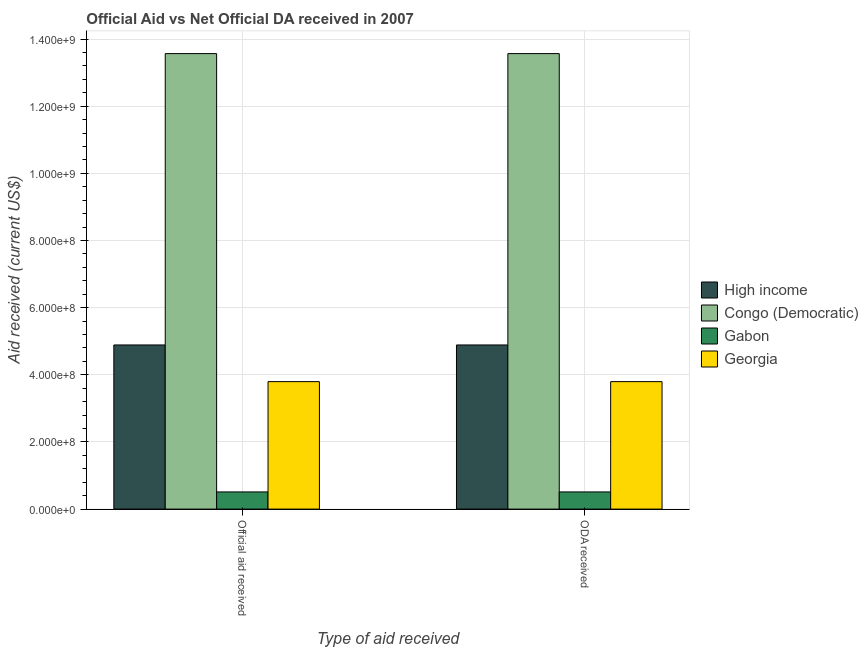How many different coloured bars are there?
Your answer should be very brief. 4. Are the number of bars per tick equal to the number of legend labels?
Offer a terse response. Yes. Are the number of bars on each tick of the X-axis equal?
Offer a terse response. Yes. How many bars are there on the 1st tick from the left?
Your response must be concise. 4. What is the label of the 1st group of bars from the left?
Your answer should be compact. Official aid received. What is the oda received in Gabon?
Give a very brief answer. 5.11e+07. Across all countries, what is the maximum official aid received?
Offer a terse response. 1.36e+09. Across all countries, what is the minimum official aid received?
Offer a very short reply. 5.11e+07. In which country was the official aid received maximum?
Provide a succinct answer. Congo (Democratic). In which country was the official aid received minimum?
Offer a very short reply. Gabon. What is the total oda received in the graph?
Your response must be concise. 2.28e+09. What is the difference between the oda received in High income and that in Congo (Democratic)?
Your answer should be compact. -8.68e+08. What is the difference between the oda received in Congo (Democratic) and the official aid received in Gabon?
Your answer should be compact. 1.31e+09. What is the average oda received per country?
Your answer should be compact. 5.69e+08. In how many countries, is the oda received greater than 1120000000 US$?
Offer a very short reply. 1. What is the ratio of the oda received in High income to that in Gabon?
Give a very brief answer. 9.56. What does the 4th bar from the left in Official aid received represents?
Your answer should be compact. Georgia. What does the 2nd bar from the right in ODA received represents?
Ensure brevity in your answer.  Gabon. Are the values on the major ticks of Y-axis written in scientific E-notation?
Ensure brevity in your answer.  Yes. Does the graph contain grids?
Your answer should be very brief. Yes. Where does the legend appear in the graph?
Give a very brief answer. Center right. How many legend labels are there?
Your response must be concise. 4. What is the title of the graph?
Make the answer very short. Official Aid vs Net Official DA received in 2007 . What is the label or title of the X-axis?
Keep it short and to the point. Type of aid received. What is the label or title of the Y-axis?
Provide a succinct answer. Aid received (current US$). What is the Aid received (current US$) of High income in Official aid received?
Give a very brief answer. 4.89e+08. What is the Aid received (current US$) in Congo (Democratic) in Official aid received?
Keep it short and to the point. 1.36e+09. What is the Aid received (current US$) in Gabon in Official aid received?
Keep it short and to the point. 5.11e+07. What is the Aid received (current US$) in Georgia in Official aid received?
Provide a succinct answer. 3.80e+08. What is the Aid received (current US$) of High income in ODA received?
Offer a terse response. 4.89e+08. What is the Aid received (current US$) in Congo (Democratic) in ODA received?
Make the answer very short. 1.36e+09. What is the Aid received (current US$) in Gabon in ODA received?
Ensure brevity in your answer.  5.11e+07. What is the Aid received (current US$) in Georgia in ODA received?
Give a very brief answer. 3.80e+08. Across all Type of aid received, what is the maximum Aid received (current US$) of High income?
Keep it short and to the point. 4.89e+08. Across all Type of aid received, what is the maximum Aid received (current US$) in Congo (Democratic)?
Offer a very short reply. 1.36e+09. Across all Type of aid received, what is the maximum Aid received (current US$) in Gabon?
Offer a very short reply. 5.11e+07. Across all Type of aid received, what is the maximum Aid received (current US$) of Georgia?
Keep it short and to the point. 3.80e+08. Across all Type of aid received, what is the minimum Aid received (current US$) in High income?
Provide a succinct answer. 4.89e+08. Across all Type of aid received, what is the minimum Aid received (current US$) in Congo (Democratic)?
Your response must be concise. 1.36e+09. Across all Type of aid received, what is the minimum Aid received (current US$) in Gabon?
Your response must be concise. 5.11e+07. Across all Type of aid received, what is the minimum Aid received (current US$) in Georgia?
Give a very brief answer. 3.80e+08. What is the total Aid received (current US$) in High income in the graph?
Your answer should be compact. 9.78e+08. What is the total Aid received (current US$) in Congo (Democratic) in the graph?
Provide a short and direct response. 2.71e+09. What is the total Aid received (current US$) of Gabon in the graph?
Ensure brevity in your answer.  1.02e+08. What is the total Aid received (current US$) in Georgia in the graph?
Ensure brevity in your answer.  7.59e+08. What is the difference between the Aid received (current US$) in High income in Official aid received and that in ODA received?
Offer a terse response. 0. What is the difference between the Aid received (current US$) of High income in Official aid received and the Aid received (current US$) of Congo (Democratic) in ODA received?
Your answer should be compact. -8.68e+08. What is the difference between the Aid received (current US$) of High income in Official aid received and the Aid received (current US$) of Gabon in ODA received?
Provide a short and direct response. 4.38e+08. What is the difference between the Aid received (current US$) of High income in Official aid received and the Aid received (current US$) of Georgia in ODA received?
Your answer should be very brief. 1.09e+08. What is the difference between the Aid received (current US$) in Congo (Democratic) in Official aid received and the Aid received (current US$) in Gabon in ODA received?
Your answer should be very brief. 1.31e+09. What is the difference between the Aid received (current US$) of Congo (Democratic) in Official aid received and the Aid received (current US$) of Georgia in ODA received?
Provide a succinct answer. 9.77e+08. What is the difference between the Aid received (current US$) of Gabon in Official aid received and the Aid received (current US$) of Georgia in ODA received?
Make the answer very short. -3.29e+08. What is the average Aid received (current US$) of High income per Type of aid received?
Keep it short and to the point. 4.89e+08. What is the average Aid received (current US$) of Congo (Democratic) per Type of aid received?
Offer a terse response. 1.36e+09. What is the average Aid received (current US$) of Gabon per Type of aid received?
Offer a terse response. 5.11e+07. What is the average Aid received (current US$) in Georgia per Type of aid received?
Ensure brevity in your answer.  3.80e+08. What is the difference between the Aid received (current US$) of High income and Aid received (current US$) of Congo (Democratic) in Official aid received?
Make the answer very short. -8.68e+08. What is the difference between the Aid received (current US$) in High income and Aid received (current US$) in Gabon in Official aid received?
Ensure brevity in your answer.  4.38e+08. What is the difference between the Aid received (current US$) in High income and Aid received (current US$) in Georgia in Official aid received?
Your answer should be very brief. 1.09e+08. What is the difference between the Aid received (current US$) of Congo (Democratic) and Aid received (current US$) of Gabon in Official aid received?
Keep it short and to the point. 1.31e+09. What is the difference between the Aid received (current US$) of Congo (Democratic) and Aid received (current US$) of Georgia in Official aid received?
Offer a very short reply. 9.77e+08. What is the difference between the Aid received (current US$) of Gabon and Aid received (current US$) of Georgia in Official aid received?
Make the answer very short. -3.29e+08. What is the difference between the Aid received (current US$) of High income and Aid received (current US$) of Congo (Democratic) in ODA received?
Provide a succinct answer. -8.68e+08. What is the difference between the Aid received (current US$) in High income and Aid received (current US$) in Gabon in ODA received?
Offer a terse response. 4.38e+08. What is the difference between the Aid received (current US$) in High income and Aid received (current US$) in Georgia in ODA received?
Your answer should be very brief. 1.09e+08. What is the difference between the Aid received (current US$) of Congo (Democratic) and Aid received (current US$) of Gabon in ODA received?
Offer a terse response. 1.31e+09. What is the difference between the Aid received (current US$) in Congo (Democratic) and Aid received (current US$) in Georgia in ODA received?
Make the answer very short. 9.77e+08. What is the difference between the Aid received (current US$) in Gabon and Aid received (current US$) in Georgia in ODA received?
Your answer should be very brief. -3.29e+08. What is the ratio of the Aid received (current US$) in Georgia in Official aid received to that in ODA received?
Keep it short and to the point. 1. What is the difference between the highest and the second highest Aid received (current US$) in High income?
Your answer should be very brief. 0. What is the difference between the highest and the second highest Aid received (current US$) of Gabon?
Provide a short and direct response. 0. What is the difference between the highest and the lowest Aid received (current US$) in Gabon?
Offer a terse response. 0. 